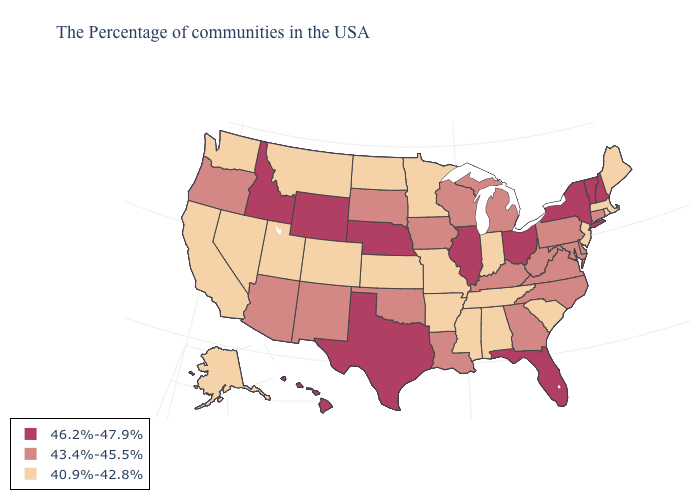Which states have the lowest value in the USA?
Keep it brief. Maine, Massachusetts, Rhode Island, New Jersey, South Carolina, Indiana, Alabama, Tennessee, Mississippi, Missouri, Arkansas, Minnesota, Kansas, North Dakota, Colorado, Utah, Montana, Nevada, California, Washington, Alaska. Which states hav the highest value in the MidWest?
Short answer required. Ohio, Illinois, Nebraska. What is the value of Oregon?
Short answer required. 43.4%-45.5%. What is the highest value in states that border Mississippi?
Short answer required. 43.4%-45.5%. Name the states that have a value in the range 43.4%-45.5%?
Write a very short answer. Connecticut, Delaware, Maryland, Pennsylvania, Virginia, North Carolina, West Virginia, Georgia, Michigan, Kentucky, Wisconsin, Louisiana, Iowa, Oklahoma, South Dakota, New Mexico, Arizona, Oregon. Among the states that border Michigan , does Ohio have the highest value?
Be succinct. Yes. What is the value of Arkansas?
Concise answer only. 40.9%-42.8%. Among the states that border Colorado , which have the highest value?
Short answer required. Nebraska, Wyoming. Does Arkansas have the lowest value in the South?
Quick response, please. Yes. Among the states that border Nevada , does Arizona have the lowest value?
Short answer required. No. What is the lowest value in the USA?
Quick response, please. 40.9%-42.8%. Among the states that border Kentucky , does West Virginia have the highest value?
Give a very brief answer. No. Name the states that have a value in the range 43.4%-45.5%?
Short answer required. Connecticut, Delaware, Maryland, Pennsylvania, Virginia, North Carolina, West Virginia, Georgia, Michigan, Kentucky, Wisconsin, Louisiana, Iowa, Oklahoma, South Dakota, New Mexico, Arizona, Oregon. What is the value of Florida?
Answer briefly. 46.2%-47.9%. What is the value of Texas?
Answer briefly. 46.2%-47.9%. 